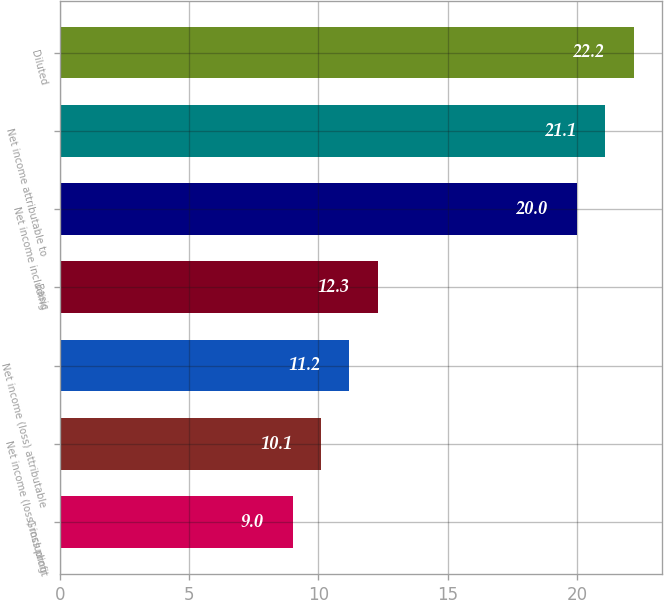Convert chart. <chart><loc_0><loc_0><loc_500><loc_500><bar_chart><fcel>Gross profit<fcel>Net income (loss) including<fcel>Net income (loss) attributable<fcel>Basic<fcel>Net income including<fcel>Net income attributable to<fcel>Diluted<nl><fcel>9<fcel>10.1<fcel>11.2<fcel>12.3<fcel>20<fcel>21.1<fcel>22.2<nl></chart> 